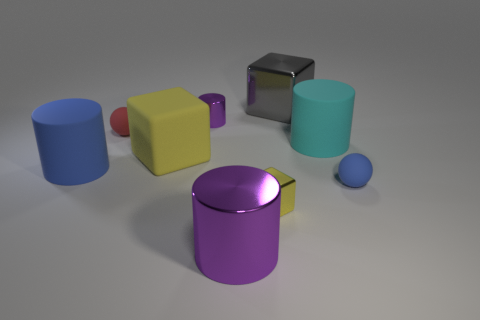There is a purple metal thing that is in front of the big cube that is in front of the large gray block; what is its shape?
Provide a short and direct response. Cylinder. Are there any blue matte things of the same shape as the small purple object?
Offer a very short reply. Yes. Do the large metal block and the matte cylinder right of the big shiny cube have the same color?
Give a very brief answer. No. What is the size of the other cylinder that is the same color as the tiny metallic cylinder?
Keep it short and to the point. Large. Are there any yellow matte cylinders of the same size as the cyan matte thing?
Make the answer very short. No. Is the tiny blue sphere made of the same material as the blue object on the left side of the tiny red ball?
Keep it short and to the point. Yes. Is the number of big shiny objects greater than the number of big cyan matte cylinders?
Your answer should be compact. Yes. What number of cubes are either blue things or tiny cyan rubber things?
Keep it short and to the point. 0. The big matte cube has what color?
Make the answer very short. Yellow. Is the size of the yellow block that is behind the tiny yellow shiny block the same as the blue rubber thing right of the tiny red rubber thing?
Your answer should be compact. No. 